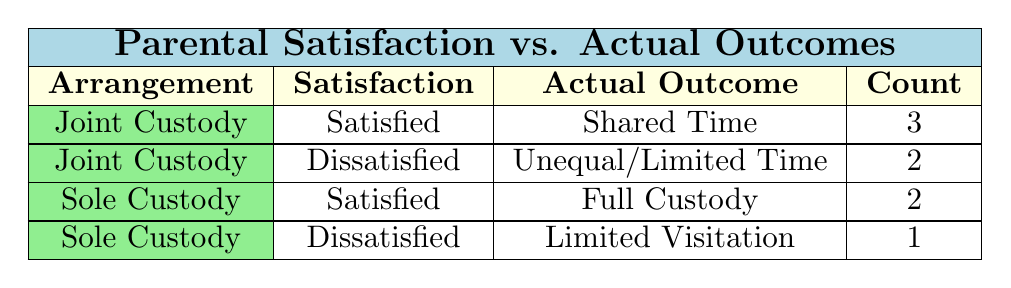What is the total count of parents who are satisfied with joint custody arrangements? From the table, we can see that there are three entries where the custody arrangement is "Joint Custody" and the satisfaction is "Satisfied." The counts corresponding to this condition are 3 from the row for "Shared Time."
Answer: 3 How many parents expressed dissatisfaction with sole custody arrangements? Looking at the table, there is one entry with "Sole Custody" and "Dissatisfied," which corresponds to limited visitation. Thus, the count is 1 parent.
Answer: 1 Is there any parent who is dissatisfied with joint custody and has unlimited visitation? Upon examining the entries for joint custody with dissatisfaction, both parents report having unequal or limited time, specifically either "Unequal Time (70/30)" or "Limited Visitation (Once a Month)." Therefore, the statement is false.
Answer: No What is the count of parents who are satisfied with sole custody compared to those who are satisfied with joint custody? The table shows that 2 parents are satisfied with sole custody (both having full custody) while 3 parents are satisfied with joint custody (having shared time). Thus, overall the count of joint custody satisfactions exceed sole custody.
Answer: Joint Custody: 3, Sole Custody: 2 Which actual outcome was reported by the most satisfied parents? The actual outcome for satisfied parents includes both shared time and full custody. The most common actual outcome among satisfied parents is shared time, reported by 3 parents.
Answer: Shared Time How many parents report an outcome of limited visitation? From the table, there are two entries with limited visitation, one for a "Sole Custody" arrangement (1 parent) and the other from a "Joint Custody" arrangement (1 parent). Summing these gives us a total of 2 parents.
Answer: 2 Do more parents have actual outcomes of shared time compared to those with limited visitation? There are 3 parents with shared time and 2 parents with limited visitation. So, it is evident that shared time outcomes outnumber limited visitation outcomes.
Answer: Yes What is the percentage of parents satisfied with their custody arrangements? There are 5 parents who are satisfied out of a total of 8 parents surveyed. To find the percentage, we divide 5 by 8 and multiply by 100, which gives us 62.5%.
Answer: 62.5% What’s the count of parents who have joint custody but are dissatisfied? In the table, there are two entries reflecting dissatisfaction under the joint custody arrangement, one corresponding to "Unequal Time (70/30)" and the other to "Limited Visitation (Once a Month)," totaling to 2 parents.
Answer: 2 